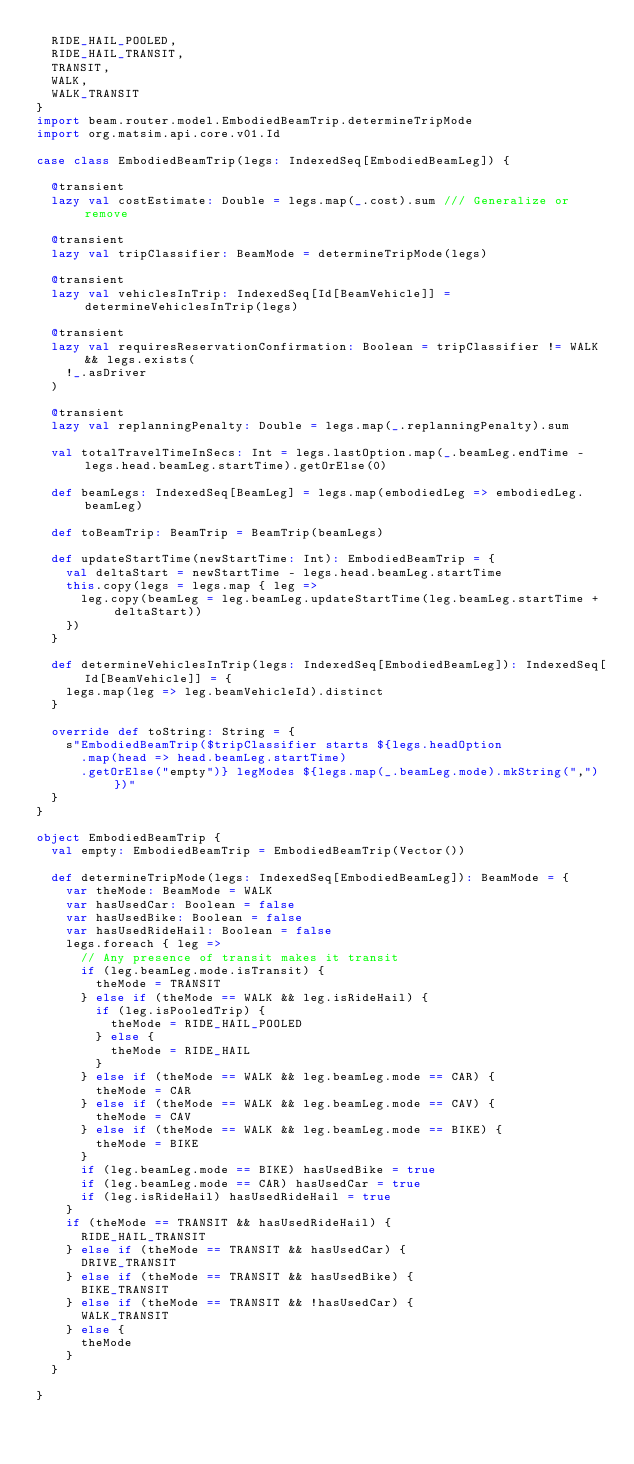<code> <loc_0><loc_0><loc_500><loc_500><_Scala_>  RIDE_HAIL_POOLED,
  RIDE_HAIL_TRANSIT,
  TRANSIT,
  WALK,
  WALK_TRANSIT
}
import beam.router.model.EmbodiedBeamTrip.determineTripMode
import org.matsim.api.core.v01.Id

case class EmbodiedBeamTrip(legs: IndexedSeq[EmbodiedBeamLeg]) {

  @transient
  lazy val costEstimate: Double = legs.map(_.cost).sum /// Generalize or remove

  @transient
  lazy val tripClassifier: BeamMode = determineTripMode(legs)

  @transient
  lazy val vehiclesInTrip: IndexedSeq[Id[BeamVehicle]] = determineVehiclesInTrip(legs)

  @transient
  lazy val requiresReservationConfirmation: Boolean = tripClassifier != WALK && legs.exists(
    !_.asDriver
  )

  @transient
  lazy val replanningPenalty: Double = legs.map(_.replanningPenalty).sum

  val totalTravelTimeInSecs: Int = legs.lastOption.map(_.beamLeg.endTime - legs.head.beamLeg.startTime).getOrElse(0)

  def beamLegs: IndexedSeq[BeamLeg] = legs.map(embodiedLeg => embodiedLeg.beamLeg)

  def toBeamTrip: BeamTrip = BeamTrip(beamLegs)

  def updateStartTime(newStartTime: Int): EmbodiedBeamTrip = {
    val deltaStart = newStartTime - legs.head.beamLeg.startTime
    this.copy(legs = legs.map { leg =>
      leg.copy(beamLeg = leg.beamLeg.updateStartTime(leg.beamLeg.startTime + deltaStart))
    })
  }

  def determineVehiclesInTrip(legs: IndexedSeq[EmbodiedBeamLeg]): IndexedSeq[Id[BeamVehicle]] = {
    legs.map(leg => leg.beamVehicleId).distinct
  }

  override def toString: String = {
    s"EmbodiedBeamTrip($tripClassifier starts ${legs.headOption
      .map(head => head.beamLeg.startTime)
      .getOrElse("empty")} legModes ${legs.map(_.beamLeg.mode).mkString(",")})"
  }
}

object EmbodiedBeamTrip {
  val empty: EmbodiedBeamTrip = EmbodiedBeamTrip(Vector())

  def determineTripMode(legs: IndexedSeq[EmbodiedBeamLeg]): BeamMode = {
    var theMode: BeamMode = WALK
    var hasUsedCar: Boolean = false
    var hasUsedBike: Boolean = false
    var hasUsedRideHail: Boolean = false
    legs.foreach { leg =>
      // Any presence of transit makes it transit
      if (leg.beamLeg.mode.isTransit) {
        theMode = TRANSIT
      } else if (theMode == WALK && leg.isRideHail) {
        if (leg.isPooledTrip) {
          theMode = RIDE_HAIL_POOLED
        } else {
          theMode = RIDE_HAIL
        }
      } else if (theMode == WALK && leg.beamLeg.mode == CAR) {
        theMode = CAR
      } else if (theMode == WALK && leg.beamLeg.mode == CAV) {
        theMode = CAV
      } else if (theMode == WALK && leg.beamLeg.mode == BIKE) {
        theMode = BIKE
      }
      if (leg.beamLeg.mode == BIKE) hasUsedBike = true
      if (leg.beamLeg.mode == CAR) hasUsedCar = true
      if (leg.isRideHail) hasUsedRideHail = true
    }
    if (theMode == TRANSIT && hasUsedRideHail) {
      RIDE_HAIL_TRANSIT
    } else if (theMode == TRANSIT && hasUsedCar) {
      DRIVE_TRANSIT
    } else if (theMode == TRANSIT && hasUsedBike) {
      BIKE_TRANSIT
    } else if (theMode == TRANSIT && !hasUsedCar) {
      WALK_TRANSIT
    } else {
      theMode
    }
  }

}
</code> 